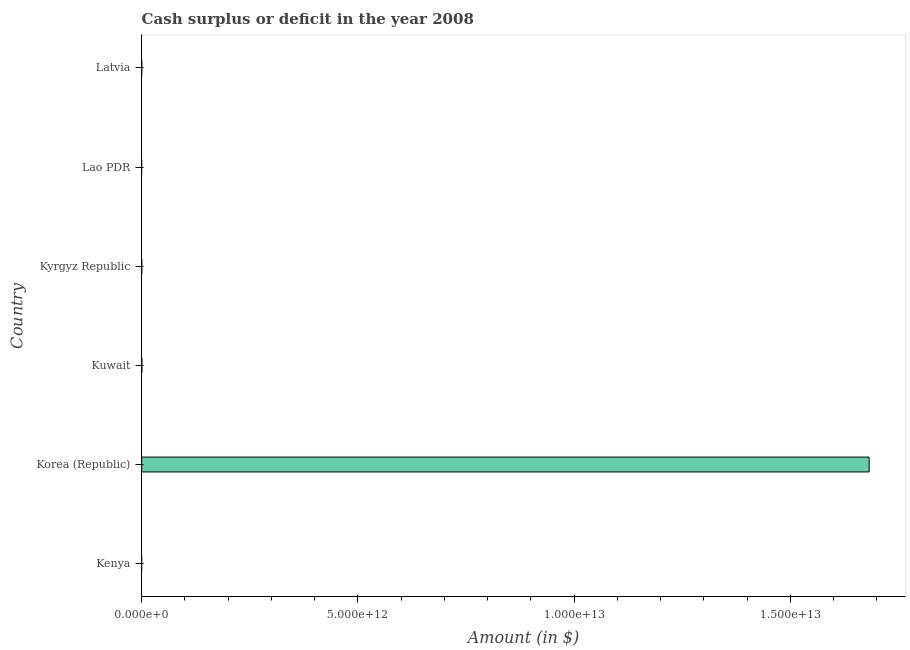What is the title of the graph?
Offer a terse response. Cash surplus or deficit in the year 2008. What is the label or title of the X-axis?
Offer a terse response. Amount (in $). What is the label or title of the Y-axis?
Your answer should be very brief. Country. What is the cash surplus or deficit in Kuwait?
Ensure brevity in your answer.  2.00e+09. Across all countries, what is the maximum cash surplus or deficit?
Keep it short and to the point. 1.68e+13. Across all countries, what is the minimum cash surplus or deficit?
Offer a very short reply. 0. What is the sum of the cash surplus or deficit?
Provide a short and direct response. 1.68e+13. What is the difference between the cash surplus or deficit in Korea (Republic) and Kuwait?
Make the answer very short. 1.68e+13. What is the average cash surplus or deficit per country?
Your answer should be compact. 2.80e+12. What is the median cash surplus or deficit?
Offer a terse response. 0. Is the sum of the cash surplus or deficit in Korea (Republic) and Kuwait greater than the maximum cash surplus or deficit across all countries?
Provide a short and direct response. Yes. What is the difference between the highest and the lowest cash surplus or deficit?
Offer a very short reply. 1.68e+13. How many countries are there in the graph?
Your answer should be very brief. 6. What is the difference between two consecutive major ticks on the X-axis?
Your response must be concise. 5.00e+12. Are the values on the major ticks of X-axis written in scientific E-notation?
Provide a succinct answer. Yes. What is the Amount (in $) of Korea (Republic)?
Offer a terse response. 1.68e+13. What is the Amount (in $) of Kuwait?
Your answer should be very brief. 2.00e+09. What is the Amount (in $) in Lao PDR?
Keep it short and to the point. 0. What is the difference between the Amount (in $) in Korea (Republic) and Kuwait?
Your answer should be compact. 1.68e+13. What is the ratio of the Amount (in $) in Korea (Republic) to that in Kuwait?
Your response must be concise. 8389.77. 